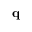<formula> <loc_0><loc_0><loc_500><loc_500>q</formula> 